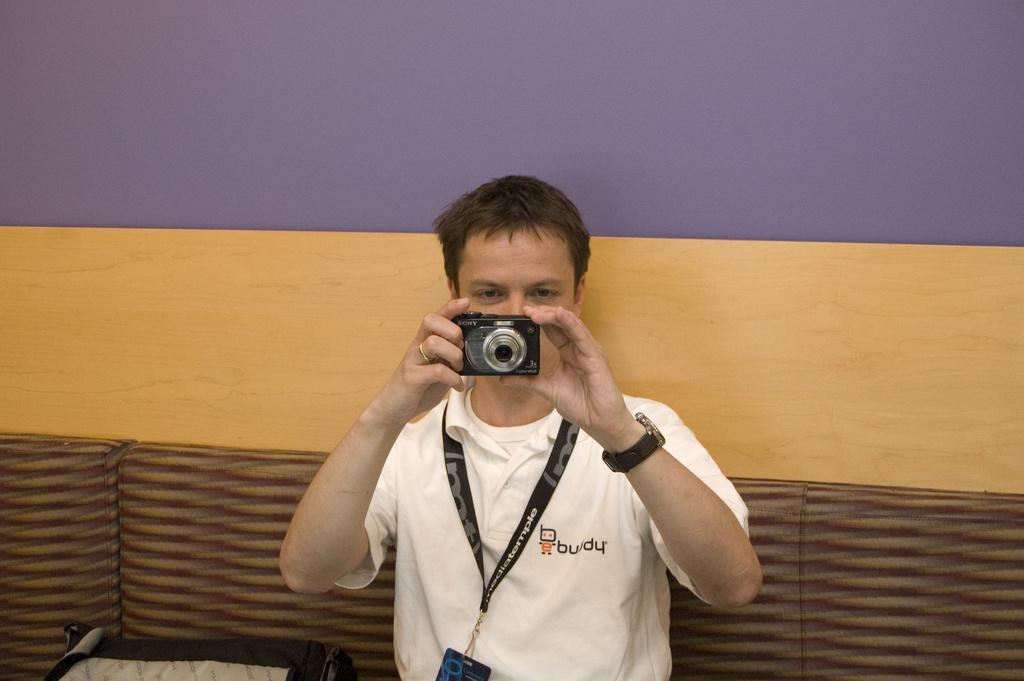How would you summarize this image in a sentence or two? There is a man in white color t-shirt, capturing a photo with the camera. In the background, there is a wall color with blue and brown. And there is a sofa below to this wall. 